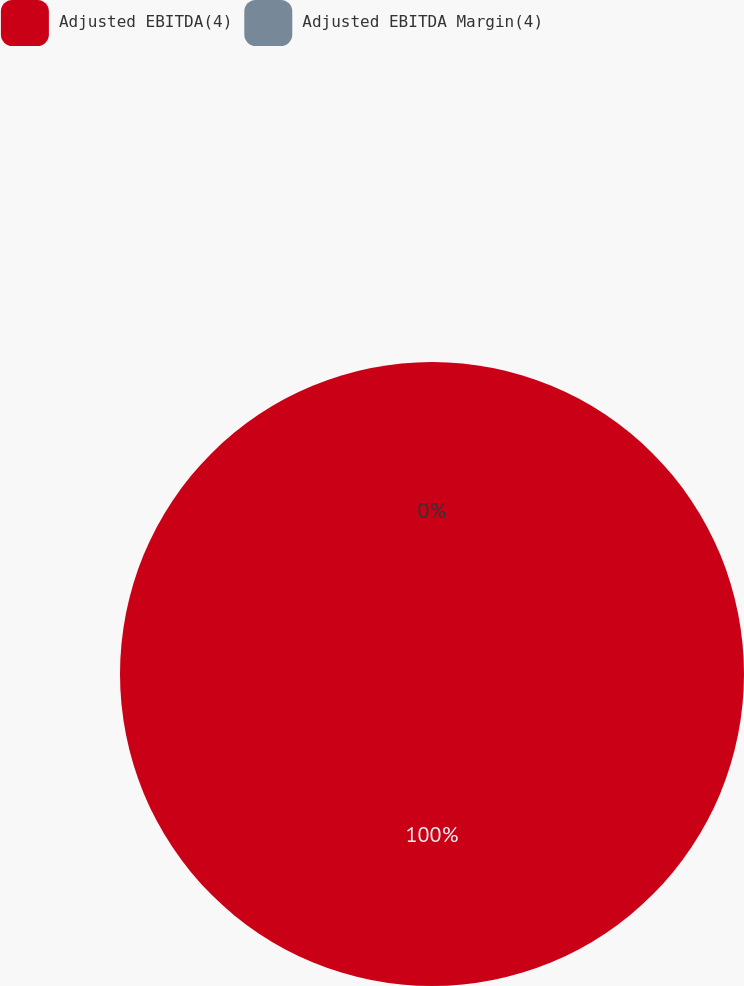<chart> <loc_0><loc_0><loc_500><loc_500><pie_chart><fcel>Adjusted EBITDA(4)<fcel>Adjusted EBITDA Margin(4)<nl><fcel>100.0%<fcel>0.0%<nl></chart> 